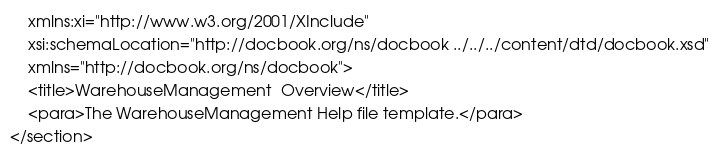<code> <loc_0><loc_0><loc_500><loc_500><_XML_>    xmlns:xi="http://www.w3.org/2001/XInclude"
    xsi:schemaLocation="http://docbook.org/ns/docbook ../../../content/dtd/docbook.xsd"
    xmlns="http://docbook.org/ns/docbook">
    <title>WarehouseManagement  Overview</title>
    <para>The WarehouseManagement Help file template.</para>
</section>

</code> 